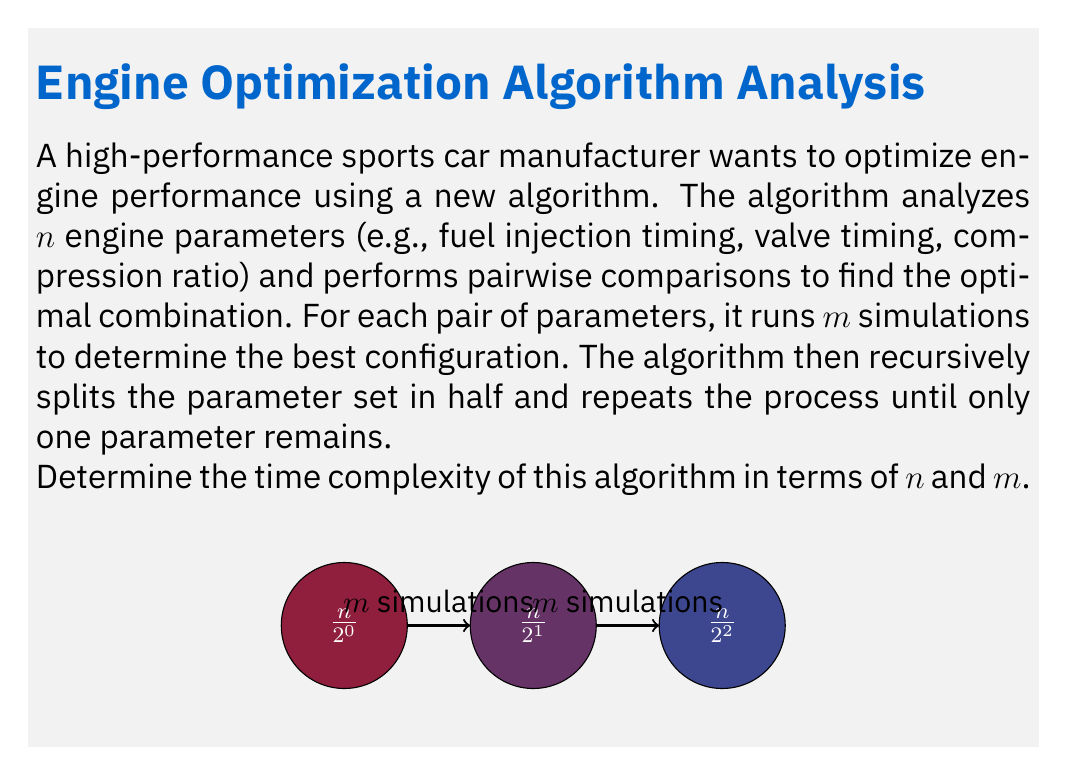Give your solution to this math problem. Let's break down the algorithm and analyze its time complexity step by step:

1) The algorithm starts with $n$ parameters and performs pairwise comparisons.

2) In each level of recursion, the number of parameters is halved.

3) The number of levels in the recursion tree is $\log_2(n)$, as we keep dividing by 2 until we reach 1.

4) At each level $i$ (starting from 0), we have:
   - Number of parameters: $n/2^i$
   - Number of pairwise comparisons: $\binom{n/2^i}{2} = \frac{(n/2^i)(n/2^i - 1)}{2}$
   - Each comparison involves $m$ simulations

5) The time complexity for level $i$ is:
   $$T_i = m \cdot \frac{(n/2^i)(n/2^i - 1)}{2} = O(m \cdot (n/2^i)^2)$$

6) To get the total time complexity, we sum over all levels:
   $$T = \sum_{i=0}^{\log_2(n)-1} O(m \cdot (n/2^i)^2)$$

7) This sum can be simplified:
   $$T = O(mn^2 \sum_{i=0}^{\log_2(n)-1} 1/4^i)$$

8) The sum $\sum_{i=0}^{\infty} 1/4^i$ converges to $4/3$, so:
   $$T = O(mn^2)$$

Therefore, the time complexity of the algorithm is $O(mn^2)$.
Answer: $O(mn^2)$ 